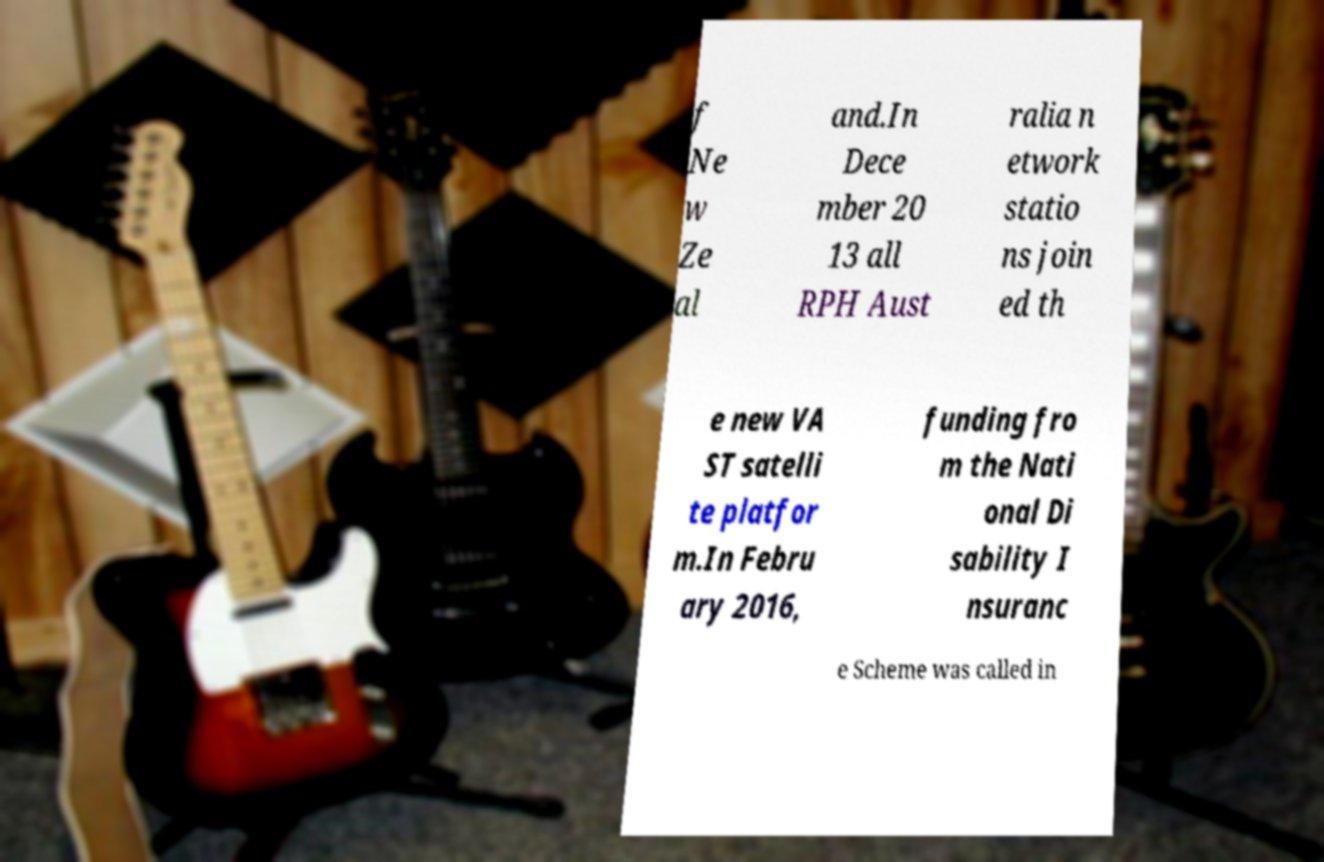Could you extract and type out the text from this image? f Ne w Ze al and.In Dece mber 20 13 all RPH Aust ralia n etwork statio ns join ed th e new VA ST satelli te platfor m.In Febru ary 2016, funding fro m the Nati onal Di sability I nsuranc e Scheme was called in 